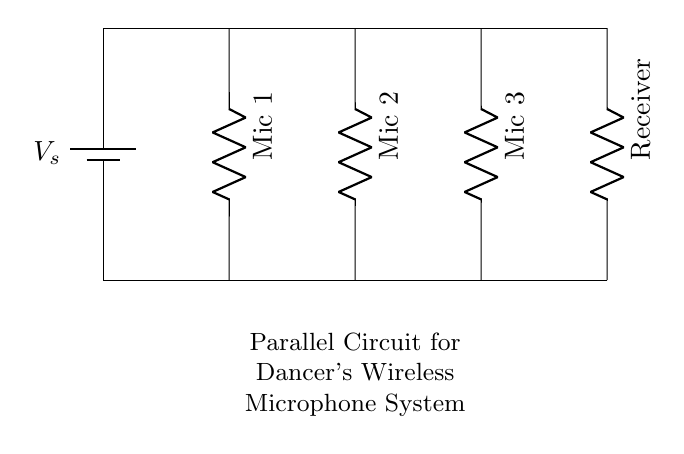What components are used in this circuit? The circuit contains a battery, three microphones, and a receiver. Each component is clearly labeled in the diagram, which allows us to identify them easily.
Answer: Battery, Microphones, Receiver What type of circuit is this? This is a parallel circuit, as indicated by the configuration where all microphones and the receiver are connected along separate branches to the same power source, allowing independent operation.
Answer: Parallel circuit How many microphones are in the circuit? The diagram shows three microphones connected parallelly. This can be counted directly on the diagram where they are labeled as Mic 1, Mic 2, and Mic 3.
Answer: Three What is the role of the receiver in this system? The receiver picks up the audio signals transmitted from the microphones. In a wireless microphone system, it is essential for converting the transmitted signals back into audio for output.
Answer: Audio conversion If one microphone fails, will the others still work? Yes, in a parallel circuit, if one branch fails (like one microphone), the others remain unaffected because each component has its own path to the power source.
Answer: Yes 